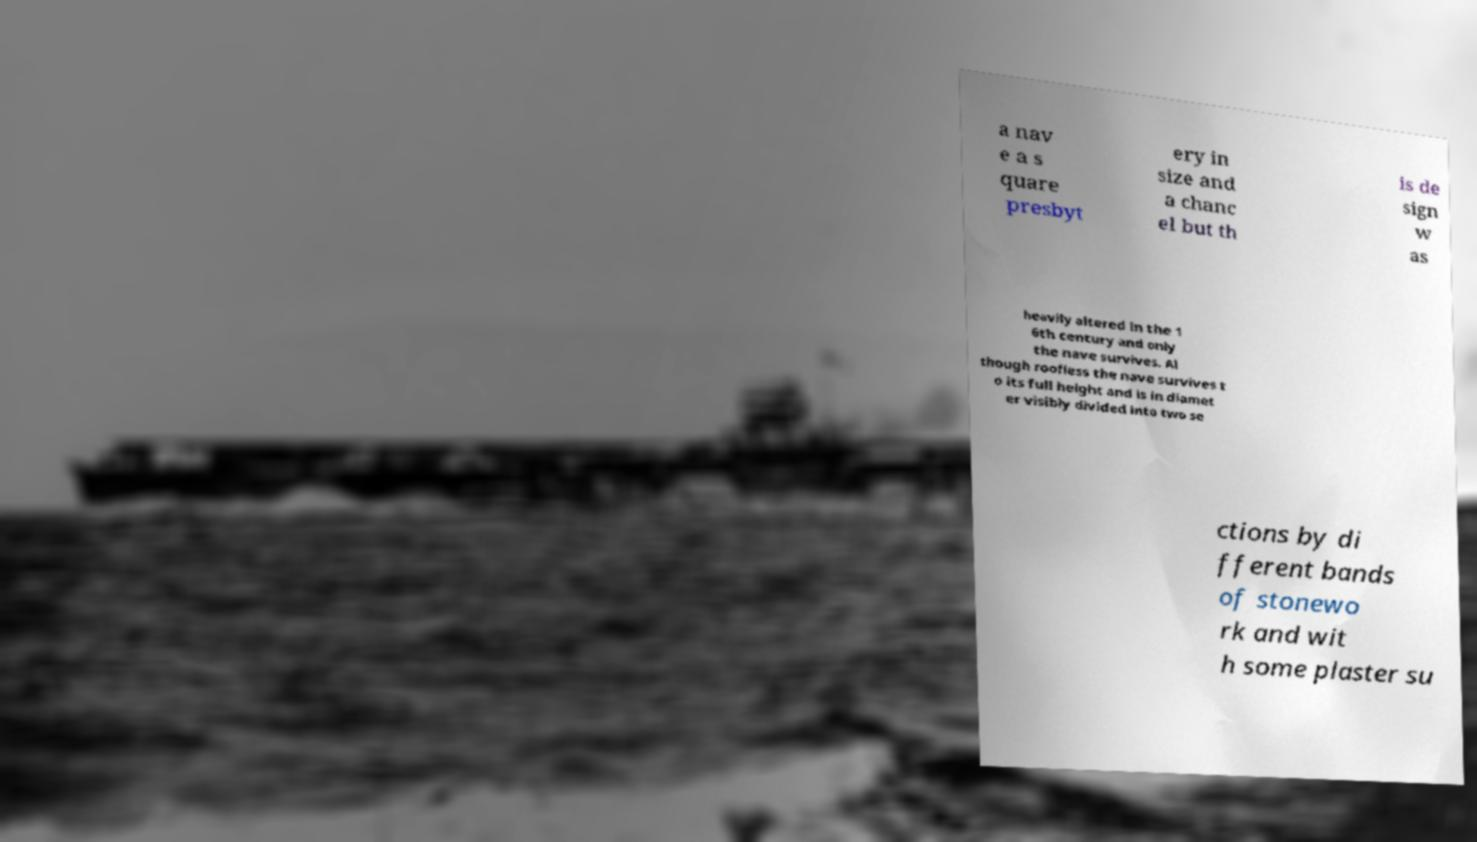Could you extract and type out the text from this image? a nav e a s quare presbyt ery in size and a chanc el but th is de sign w as heavily altered in the 1 6th century and only the nave survives. Al though roofless the nave survives t o its full height and is in diamet er visibly divided into two se ctions by di fferent bands of stonewo rk and wit h some plaster su 